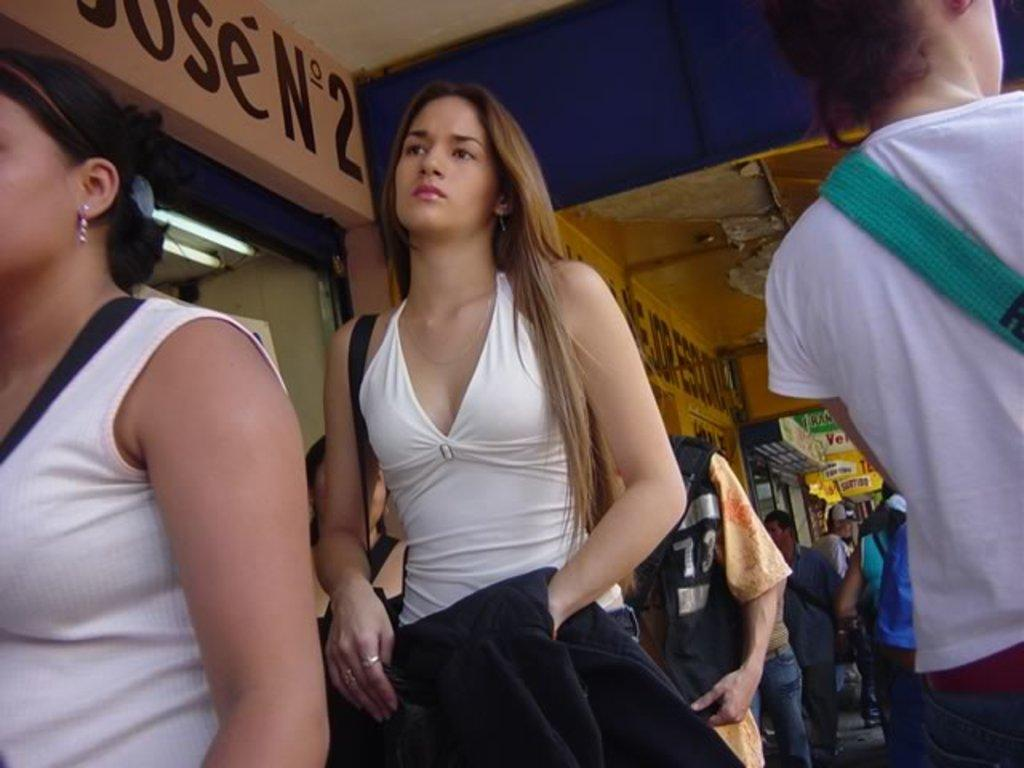Who or what is present in the image? There are people in the image. What objects can be seen in the image? There are boards and lights visible in the image. What type of structure is in the image? There is a wall in the image. Is there any text or writing in the image? Yes, there is text on the wall in the image. What type of mountain can be seen in the background of the image? There is no mountain present in the image; it features people, boards, lights, a wall, and text. 